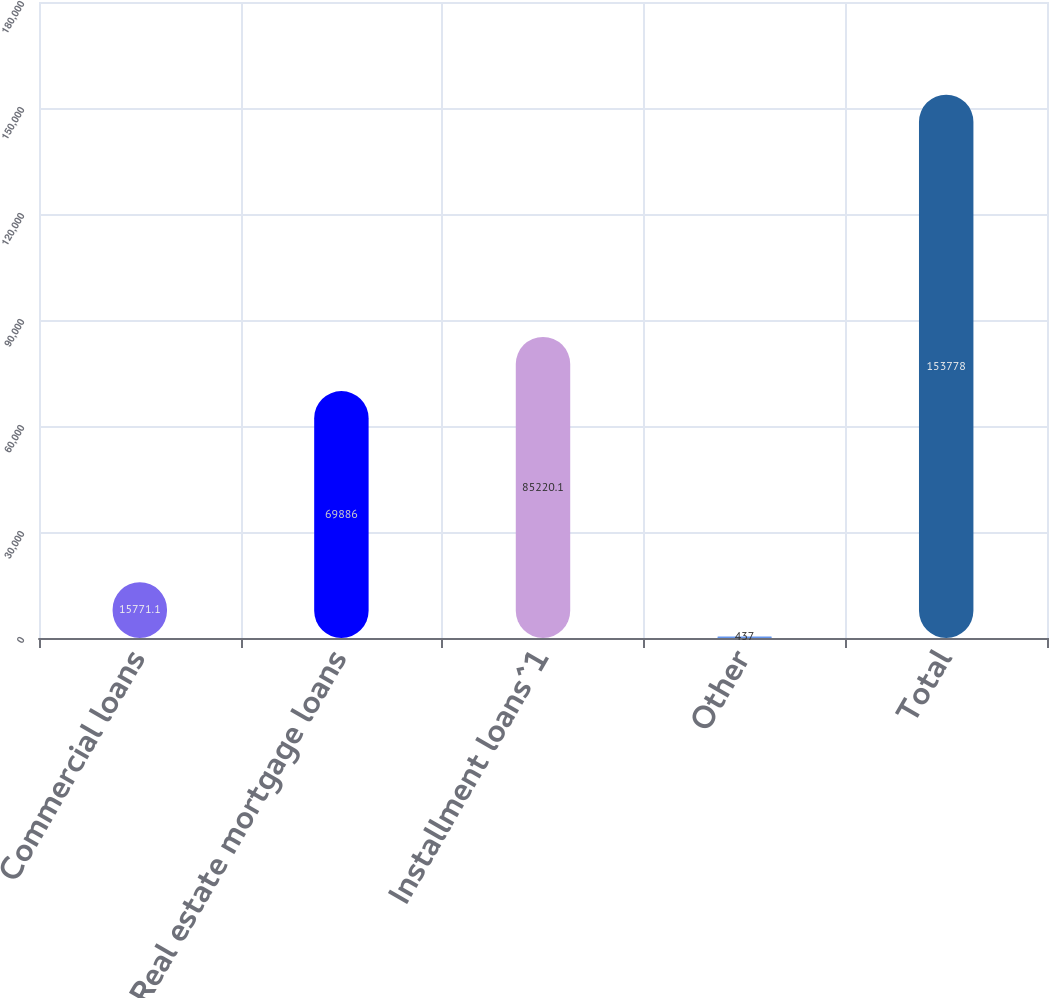Convert chart to OTSL. <chart><loc_0><loc_0><loc_500><loc_500><bar_chart><fcel>Commercial loans<fcel>Real estate mortgage loans<fcel>Installment loans^1<fcel>Other<fcel>Total<nl><fcel>15771.1<fcel>69886<fcel>85220.1<fcel>437<fcel>153778<nl></chart> 